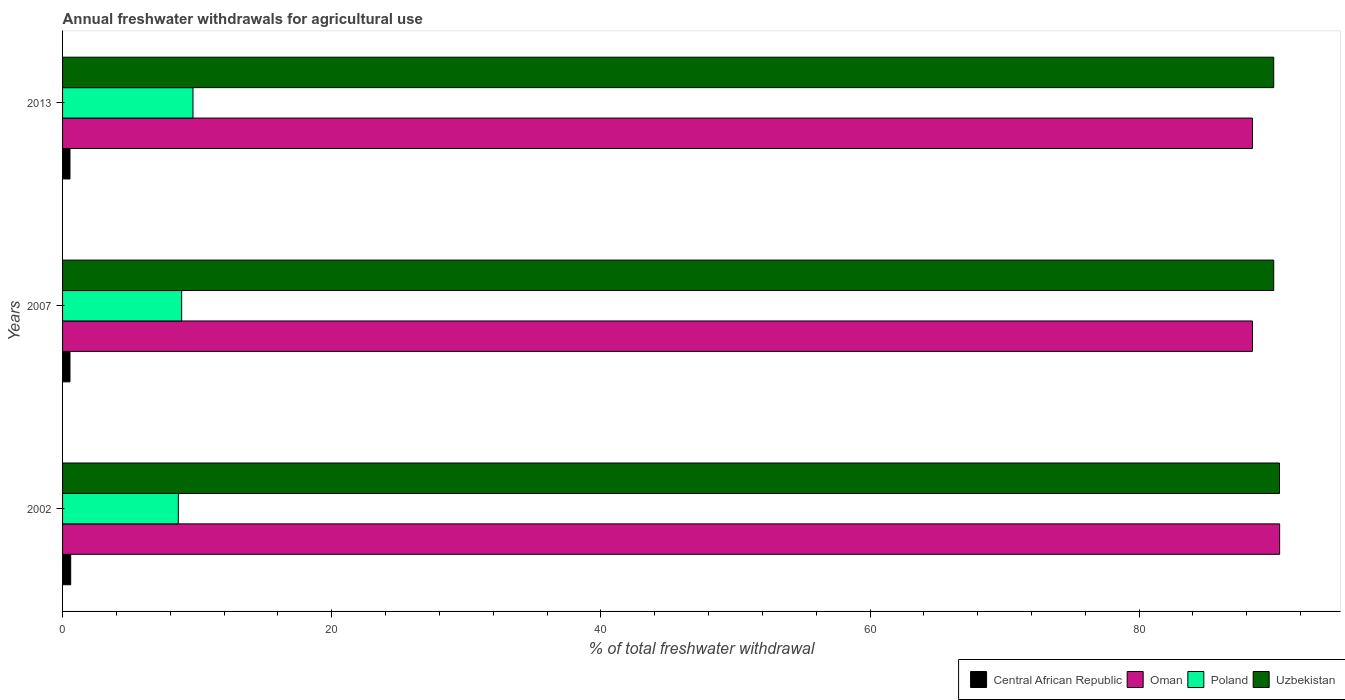How many different coloured bars are there?
Your response must be concise. 4. How many groups of bars are there?
Keep it short and to the point. 3. Are the number of bars on each tick of the Y-axis equal?
Make the answer very short. Yes. What is the total annual withdrawals from freshwater in Central African Republic in 2007?
Give a very brief answer. 0.55. Across all years, what is the maximum total annual withdrawals from freshwater in Uzbekistan?
Your response must be concise. 90.43. Across all years, what is the minimum total annual withdrawals from freshwater in Uzbekistan?
Your answer should be very brief. 90. In which year was the total annual withdrawals from freshwater in Poland minimum?
Ensure brevity in your answer.  2002. What is the total total annual withdrawals from freshwater in Oman in the graph?
Give a very brief answer. 267.28. What is the difference between the total annual withdrawals from freshwater in Oman in 2002 and that in 2013?
Your answer should be very brief. 2.02. What is the difference between the total annual withdrawals from freshwater in Oman in 2007 and the total annual withdrawals from freshwater in Central African Republic in 2013?
Your answer should be very brief. 87.87. What is the average total annual withdrawals from freshwater in Central African Republic per year?
Ensure brevity in your answer.  0.57. In the year 2013, what is the difference between the total annual withdrawals from freshwater in Uzbekistan and total annual withdrawals from freshwater in Oman?
Offer a very short reply. 1.58. In how many years, is the total annual withdrawals from freshwater in Poland greater than 28 %?
Keep it short and to the point. 0. What is the ratio of the total annual withdrawals from freshwater in Uzbekistan in 2002 to that in 2013?
Your response must be concise. 1. Is the total annual withdrawals from freshwater in Oman in 2002 less than that in 2007?
Offer a terse response. No. What is the difference between the highest and the second highest total annual withdrawals from freshwater in Uzbekistan?
Keep it short and to the point. 0.43. What is the difference between the highest and the lowest total annual withdrawals from freshwater in Poland?
Ensure brevity in your answer.  1.09. What does the 4th bar from the top in 2013 represents?
Your answer should be very brief. Central African Republic. What does the 1st bar from the bottom in 2013 represents?
Your response must be concise. Central African Republic. Is it the case that in every year, the sum of the total annual withdrawals from freshwater in Poland and total annual withdrawals from freshwater in Uzbekistan is greater than the total annual withdrawals from freshwater in Central African Republic?
Provide a short and direct response. Yes. How many bars are there?
Give a very brief answer. 12. How many years are there in the graph?
Offer a terse response. 3. Does the graph contain grids?
Provide a short and direct response. No. Where does the legend appear in the graph?
Make the answer very short. Bottom right. What is the title of the graph?
Make the answer very short. Annual freshwater withdrawals for agricultural use. What is the label or title of the X-axis?
Give a very brief answer. % of total freshwater withdrawal. What is the % of total freshwater withdrawal of Central African Republic in 2002?
Your answer should be very brief. 0.6. What is the % of total freshwater withdrawal in Oman in 2002?
Keep it short and to the point. 90.44. What is the % of total freshwater withdrawal in Poland in 2002?
Your response must be concise. 8.6. What is the % of total freshwater withdrawal in Uzbekistan in 2002?
Give a very brief answer. 90.43. What is the % of total freshwater withdrawal in Central African Republic in 2007?
Provide a short and direct response. 0.55. What is the % of total freshwater withdrawal in Oman in 2007?
Offer a terse response. 88.42. What is the % of total freshwater withdrawal of Poland in 2007?
Provide a short and direct response. 8.85. What is the % of total freshwater withdrawal in Central African Republic in 2013?
Offer a very short reply. 0.55. What is the % of total freshwater withdrawal of Oman in 2013?
Offer a terse response. 88.42. What is the % of total freshwater withdrawal in Poland in 2013?
Your response must be concise. 9.69. What is the % of total freshwater withdrawal of Uzbekistan in 2013?
Your response must be concise. 90. Across all years, what is the maximum % of total freshwater withdrawal in Central African Republic?
Give a very brief answer. 0.6. Across all years, what is the maximum % of total freshwater withdrawal in Oman?
Provide a short and direct response. 90.44. Across all years, what is the maximum % of total freshwater withdrawal of Poland?
Your answer should be compact. 9.69. Across all years, what is the maximum % of total freshwater withdrawal of Uzbekistan?
Give a very brief answer. 90.43. Across all years, what is the minimum % of total freshwater withdrawal in Central African Republic?
Your answer should be compact. 0.55. Across all years, what is the minimum % of total freshwater withdrawal of Oman?
Your response must be concise. 88.42. Across all years, what is the minimum % of total freshwater withdrawal in Poland?
Give a very brief answer. 8.6. Across all years, what is the minimum % of total freshwater withdrawal in Uzbekistan?
Ensure brevity in your answer.  90. What is the total % of total freshwater withdrawal in Central African Republic in the graph?
Your answer should be very brief. 1.71. What is the total % of total freshwater withdrawal of Oman in the graph?
Keep it short and to the point. 267.28. What is the total % of total freshwater withdrawal of Poland in the graph?
Keep it short and to the point. 27.14. What is the total % of total freshwater withdrawal of Uzbekistan in the graph?
Your answer should be very brief. 270.43. What is the difference between the % of total freshwater withdrawal of Central African Republic in 2002 and that in 2007?
Your answer should be compact. 0.05. What is the difference between the % of total freshwater withdrawal of Oman in 2002 and that in 2007?
Your answer should be very brief. 2.02. What is the difference between the % of total freshwater withdrawal in Poland in 2002 and that in 2007?
Offer a terse response. -0.25. What is the difference between the % of total freshwater withdrawal in Uzbekistan in 2002 and that in 2007?
Offer a very short reply. 0.43. What is the difference between the % of total freshwater withdrawal in Central African Republic in 2002 and that in 2013?
Your answer should be compact. 0.05. What is the difference between the % of total freshwater withdrawal in Oman in 2002 and that in 2013?
Provide a succinct answer. 2.02. What is the difference between the % of total freshwater withdrawal in Poland in 2002 and that in 2013?
Make the answer very short. -1.09. What is the difference between the % of total freshwater withdrawal in Uzbekistan in 2002 and that in 2013?
Offer a very short reply. 0.43. What is the difference between the % of total freshwater withdrawal of Poland in 2007 and that in 2013?
Your answer should be very brief. -0.84. What is the difference between the % of total freshwater withdrawal in Uzbekistan in 2007 and that in 2013?
Your response must be concise. 0. What is the difference between the % of total freshwater withdrawal of Central African Republic in 2002 and the % of total freshwater withdrawal of Oman in 2007?
Offer a terse response. -87.82. What is the difference between the % of total freshwater withdrawal of Central African Republic in 2002 and the % of total freshwater withdrawal of Poland in 2007?
Offer a terse response. -8.24. What is the difference between the % of total freshwater withdrawal of Central African Republic in 2002 and the % of total freshwater withdrawal of Uzbekistan in 2007?
Offer a very short reply. -89.4. What is the difference between the % of total freshwater withdrawal in Oman in 2002 and the % of total freshwater withdrawal in Poland in 2007?
Provide a succinct answer. 81.59. What is the difference between the % of total freshwater withdrawal in Oman in 2002 and the % of total freshwater withdrawal in Uzbekistan in 2007?
Your answer should be compact. 0.44. What is the difference between the % of total freshwater withdrawal of Poland in 2002 and the % of total freshwater withdrawal of Uzbekistan in 2007?
Offer a terse response. -81.4. What is the difference between the % of total freshwater withdrawal in Central African Republic in 2002 and the % of total freshwater withdrawal in Oman in 2013?
Your response must be concise. -87.82. What is the difference between the % of total freshwater withdrawal of Central African Republic in 2002 and the % of total freshwater withdrawal of Poland in 2013?
Make the answer very short. -9.09. What is the difference between the % of total freshwater withdrawal of Central African Republic in 2002 and the % of total freshwater withdrawal of Uzbekistan in 2013?
Offer a very short reply. -89.4. What is the difference between the % of total freshwater withdrawal of Oman in 2002 and the % of total freshwater withdrawal of Poland in 2013?
Make the answer very short. 80.75. What is the difference between the % of total freshwater withdrawal of Oman in 2002 and the % of total freshwater withdrawal of Uzbekistan in 2013?
Keep it short and to the point. 0.44. What is the difference between the % of total freshwater withdrawal of Poland in 2002 and the % of total freshwater withdrawal of Uzbekistan in 2013?
Provide a succinct answer. -81.4. What is the difference between the % of total freshwater withdrawal in Central African Republic in 2007 and the % of total freshwater withdrawal in Oman in 2013?
Provide a short and direct response. -87.87. What is the difference between the % of total freshwater withdrawal in Central African Republic in 2007 and the % of total freshwater withdrawal in Poland in 2013?
Provide a succinct answer. -9.14. What is the difference between the % of total freshwater withdrawal in Central African Republic in 2007 and the % of total freshwater withdrawal in Uzbekistan in 2013?
Your answer should be very brief. -89.45. What is the difference between the % of total freshwater withdrawal of Oman in 2007 and the % of total freshwater withdrawal of Poland in 2013?
Your answer should be very brief. 78.73. What is the difference between the % of total freshwater withdrawal of Oman in 2007 and the % of total freshwater withdrawal of Uzbekistan in 2013?
Offer a terse response. -1.58. What is the difference between the % of total freshwater withdrawal of Poland in 2007 and the % of total freshwater withdrawal of Uzbekistan in 2013?
Give a very brief answer. -81.15. What is the average % of total freshwater withdrawal in Central African Republic per year?
Provide a short and direct response. 0.57. What is the average % of total freshwater withdrawal of Oman per year?
Your response must be concise. 89.09. What is the average % of total freshwater withdrawal of Poland per year?
Provide a succinct answer. 9.05. What is the average % of total freshwater withdrawal of Uzbekistan per year?
Your answer should be very brief. 90.14. In the year 2002, what is the difference between the % of total freshwater withdrawal of Central African Republic and % of total freshwater withdrawal of Oman?
Your response must be concise. -89.84. In the year 2002, what is the difference between the % of total freshwater withdrawal in Central African Republic and % of total freshwater withdrawal in Poland?
Make the answer very short. -8. In the year 2002, what is the difference between the % of total freshwater withdrawal of Central African Republic and % of total freshwater withdrawal of Uzbekistan?
Your answer should be very brief. -89.83. In the year 2002, what is the difference between the % of total freshwater withdrawal in Oman and % of total freshwater withdrawal in Poland?
Provide a succinct answer. 81.84. In the year 2002, what is the difference between the % of total freshwater withdrawal of Poland and % of total freshwater withdrawal of Uzbekistan?
Your answer should be compact. -81.83. In the year 2007, what is the difference between the % of total freshwater withdrawal in Central African Republic and % of total freshwater withdrawal in Oman?
Offer a very short reply. -87.87. In the year 2007, what is the difference between the % of total freshwater withdrawal of Central African Republic and % of total freshwater withdrawal of Poland?
Ensure brevity in your answer.  -8.3. In the year 2007, what is the difference between the % of total freshwater withdrawal in Central African Republic and % of total freshwater withdrawal in Uzbekistan?
Offer a very short reply. -89.45. In the year 2007, what is the difference between the % of total freshwater withdrawal in Oman and % of total freshwater withdrawal in Poland?
Provide a succinct answer. 79.57. In the year 2007, what is the difference between the % of total freshwater withdrawal in Oman and % of total freshwater withdrawal in Uzbekistan?
Give a very brief answer. -1.58. In the year 2007, what is the difference between the % of total freshwater withdrawal of Poland and % of total freshwater withdrawal of Uzbekistan?
Ensure brevity in your answer.  -81.15. In the year 2013, what is the difference between the % of total freshwater withdrawal in Central African Republic and % of total freshwater withdrawal in Oman?
Make the answer very short. -87.87. In the year 2013, what is the difference between the % of total freshwater withdrawal in Central African Republic and % of total freshwater withdrawal in Poland?
Ensure brevity in your answer.  -9.14. In the year 2013, what is the difference between the % of total freshwater withdrawal of Central African Republic and % of total freshwater withdrawal of Uzbekistan?
Make the answer very short. -89.45. In the year 2013, what is the difference between the % of total freshwater withdrawal of Oman and % of total freshwater withdrawal of Poland?
Offer a very short reply. 78.73. In the year 2013, what is the difference between the % of total freshwater withdrawal in Oman and % of total freshwater withdrawal in Uzbekistan?
Your answer should be compact. -1.58. In the year 2013, what is the difference between the % of total freshwater withdrawal of Poland and % of total freshwater withdrawal of Uzbekistan?
Provide a short and direct response. -80.31. What is the ratio of the % of total freshwater withdrawal of Central African Republic in 2002 to that in 2007?
Make the answer very short. 1.1. What is the ratio of the % of total freshwater withdrawal in Oman in 2002 to that in 2007?
Keep it short and to the point. 1.02. What is the ratio of the % of total freshwater withdrawal in Poland in 2002 to that in 2007?
Offer a terse response. 0.97. What is the ratio of the % of total freshwater withdrawal in Central African Republic in 2002 to that in 2013?
Keep it short and to the point. 1.1. What is the ratio of the % of total freshwater withdrawal in Oman in 2002 to that in 2013?
Your response must be concise. 1.02. What is the ratio of the % of total freshwater withdrawal of Poland in 2002 to that in 2013?
Provide a succinct answer. 0.89. What is the ratio of the % of total freshwater withdrawal in Uzbekistan in 2002 to that in 2013?
Your response must be concise. 1. What is the ratio of the % of total freshwater withdrawal of Oman in 2007 to that in 2013?
Keep it short and to the point. 1. What is the ratio of the % of total freshwater withdrawal of Poland in 2007 to that in 2013?
Provide a succinct answer. 0.91. What is the ratio of the % of total freshwater withdrawal of Uzbekistan in 2007 to that in 2013?
Ensure brevity in your answer.  1. What is the difference between the highest and the second highest % of total freshwater withdrawal of Central African Republic?
Provide a succinct answer. 0.05. What is the difference between the highest and the second highest % of total freshwater withdrawal in Oman?
Your response must be concise. 2.02. What is the difference between the highest and the second highest % of total freshwater withdrawal of Poland?
Offer a terse response. 0.84. What is the difference between the highest and the second highest % of total freshwater withdrawal of Uzbekistan?
Make the answer very short. 0.43. What is the difference between the highest and the lowest % of total freshwater withdrawal of Central African Republic?
Give a very brief answer. 0.05. What is the difference between the highest and the lowest % of total freshwater withdrawal in Oman?
Your answer should be very brief. 2.02. What is the difference between the highest and the lowest % of total freshwater withdrawal of Poland?
Keep it short and to the point. 1.09. What is the difference between the highest and the lowest % of total freshwater withdrawal in Uzbekistan?
Your response must be concise. 0.43. 